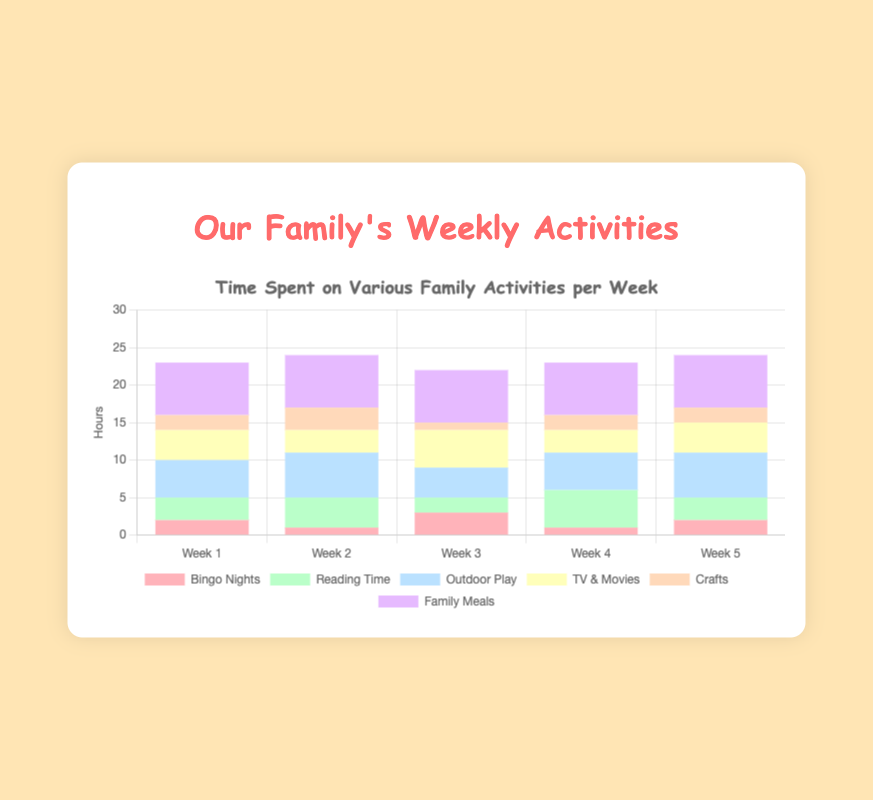How many total hours did we spend on Bingo Nights throughout the five weeks? Sum the hours spent on Bingo Nights for each week: 2 + 1 + 3 + 1 + 2 = 9 hours.
Answer: 9 Which type of activity had the highest time spent in Week 3? In Week 3, family meals had the highest hours spent at 7 hours. Compare this to the hours spent on each of the other activities.
Answer: Family Meals What was the average time spent on Outdoor Play per week? Sum the hours spent on Outdoor Play: 5 + 6 + 4 + 5 + 6 = 26. Divide by 5 weeks: 26 / 5 = 5.2 hours.
Answer: 5.2 In which week did we spend the least time watching TV & Movies? Compare the hours spent on TV & Movies across all weeks: Week 1: 4, Week 2: 3, Week 3: 5, Week 4: 3, Week 5: 4. The smallest value is 3 hours in both Week 2 and Week 4.
Answer: Week 2 and Week 4 Compare the time spent on Reading Time in Week 2 and Week 4. Which week had more hours? In Week 2, Reading Time is 4 hours; in Week 4, Reading Time is 5 hours. Compare these values: 4 < 5, so Week 4 had more hours.
Answer: Week 4 How many hours in total were spent on Family Meals across all five weeks? Sum the hours for Family Meals over the five weeks: 7 + 7 + 7 + 7 + 7 = 35 hours.
Answer: 35 